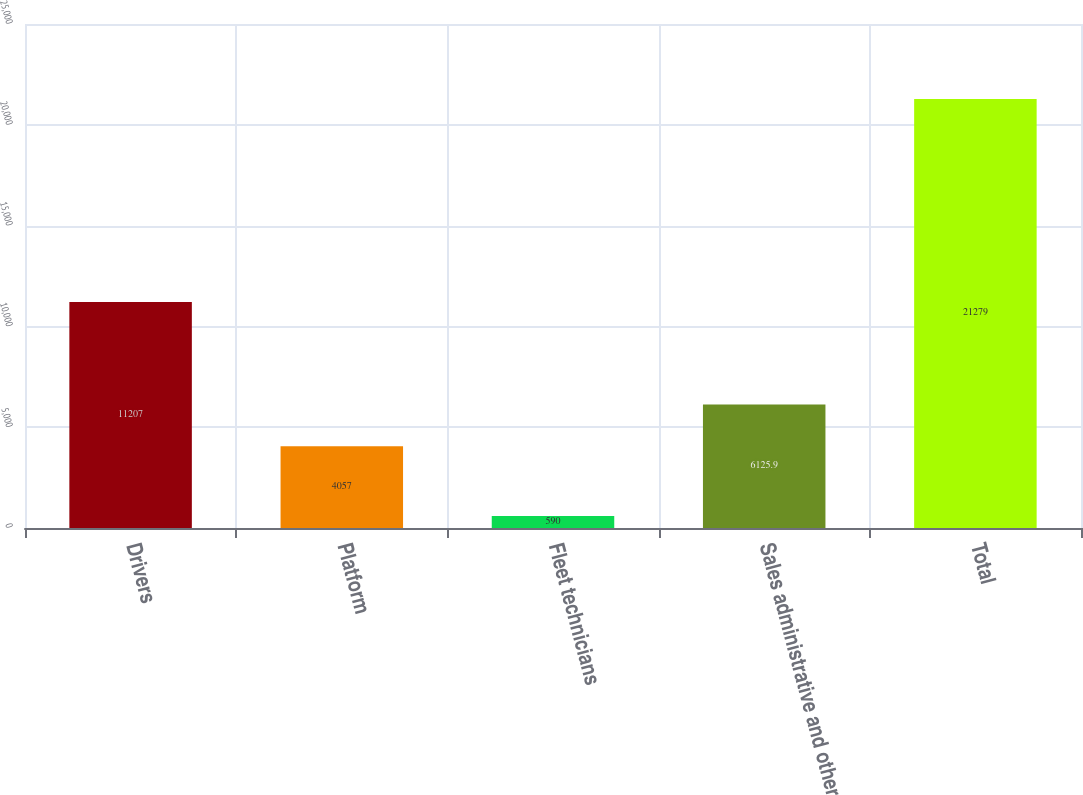Convert chart. <chart><loc_0><loc_0><loc_500><loc_500><bar_chart><fcel>Drivers<fcel>Platform<fcel>Fleet technicians<fcel>Sales administrative and other<fcel>Total<nl><fcel>11207<fcel>4057<fcel>590<fcel>6125.9<fcel>21279<nl></chart> 